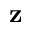Convert formula to latex. <formula><loc_0><loc_0><loc_500><loc_500>z</formula> 